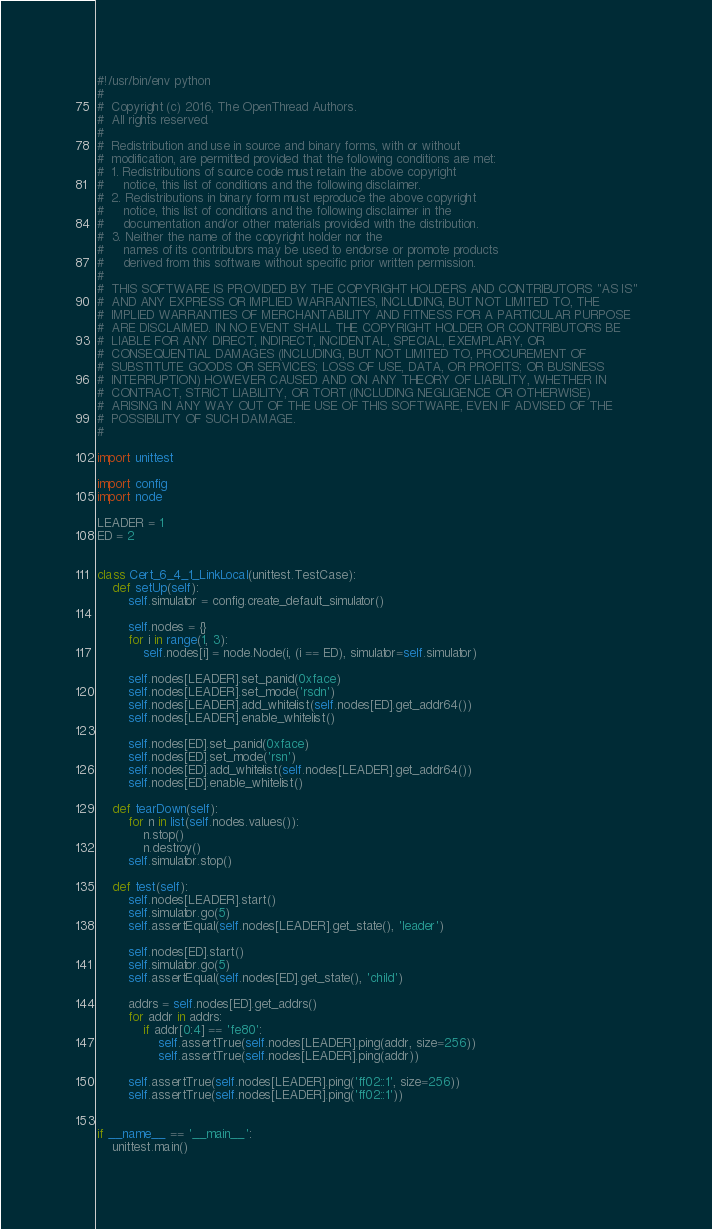<code> <loc_0><loc_0><loc_500><loc_500><_Python_>#!/usr/bin/env python
#
#  Copyright (c) 2016, The OpenThread Authors.
#  All rights reserved.
#
#  Redistribution and use in source and binary forms, with or without
#  modification, are permitted provided that the following conditions are met:
#  1. Redistributions of source code must retain the above copyright
#     notice, this list of conditions and the following disclaimer.
#  2. Redistributions in binary form must reproduce the above copyright
#     notice, this list of conditions and the following disclaimer in the
#     documentation and/or other materials provided with the distribution.
#  3. Neither the name of the copyright holder nor the
#     names of its contributors may be used to endorse or promote products
#     derived from this software without specific prior written permission.
#
#  THIS SOFTWARE IS PROVIDED BY THE COPYRIGHT HOLDERS AND CONTRIBUTORS "AS IS"
#  AND ANY EXPRESS OR IMPLIED WARRANTIES, INCLUDING, BUT NOT LIMITED TO, THE
#  IMPLIED WARRANTIES OF MERCHANTABILITY AND FITNESS FOR A PARTICULAR PURPOSE
#  ARE DISCLAIMED. IN NO EVENT SHALL THE COPYRIGHT HOLDER OR CONTRIBUTORS BE
#  LIABLE FOR ANY DIRECT, INDIRECT, INCIDENTAL, SPECIAL, EXEMPLARY, OR
#  CONSEQUENTIAL DAMAGES (INCLUDING, BUT NOT LIMITED TO, PROCUREMENT OF
#  SUBSTITUTE GOODS OR SERVICES; LOSS OF USE, DATA, OR PROFITS; OR BUSINESS
#  INTERRUPTION) HOWEVER CAUSED AND ON ANY THEORY OF LIABILITY, WHETHER IN
#  CONTRACT, STRICT LIABILITY, OR TORT (INCLUDING NEGLIGENCE OR OTHERWISE)
#  ARISING IN ANY WAY OUT OF THE USE OF THIS SOFTWARE, EVEN IF ADVISED OF THE
#  POSSIBILITY OF SUCH DAMAGE.
#

import unittest

import config
import node

LEADER = 1
ED = 2


class Cert_6_4_1_LinkLocal(unittest.TestCase):
    def setUp(self):
        self.simulator = config.create_default_simulator()

        self.nodes = {}
        for i in range(1, 3):
            self.nodes[i] = node.Node(i, (i == ED), simulator=self.simulator)

        self.nodes[LEADER].set_panid(0xface)
        self.nodes[LEADER].set_mode('rsdn')
        self.nodes[LEADER].add_whitelist(self.nodes[ED].get_addr64())
        self.nodes[LEADER].enable_whitelist()

        self.nodes[ED].set_panid(0xface)
        self.nodes[ED].set_mode('rsn')
        self.nodes[ED].add_whitelist(self.nodes[LEADER].get_addr64())
        self.nodes[ED].enable_whitelist()

    def tearDown(self):
        for n in list(self.nodes.values()):
            n.stop()
            n.destroy()
        self.simulator.stop()

    def test(self):
        self.nodes[LEADER].start()
        self.simulator.go(5)
        self.assertEqual(self.nodes[LEADER].get_state(), 'leader')

        self.nodes[ED].start()
        self.simulator.go(5)
        self.assertEqual(self.nodes[ED].get_state(), 'child')

        addrs = self.nodes[ED].get_addrs()
        for addr in addrs:
            if addr[0:4] == 'fe80':
                self.assertTrue(self.nodes[LEADER].ping(addr, size=256))
                self.assertTrue(self.nodes[LEADER].ping(addr))

        self.assertTrue(self.nodes[LEADER].ping('ff02::1', size=256))
        self.assertTrue(self.nodes[LEADER].ping('ff02::1'))


if __name__ == '__main__':
    unittest.main()
</code> 